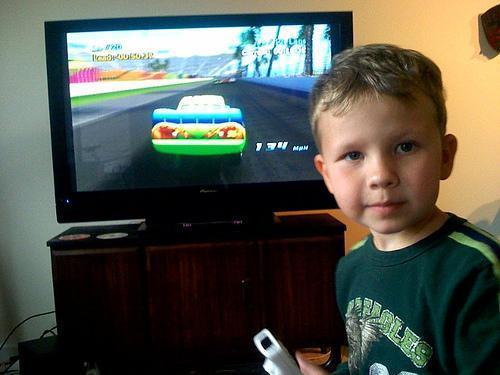How many boys in photo?
Give a very brief answer. 1. 